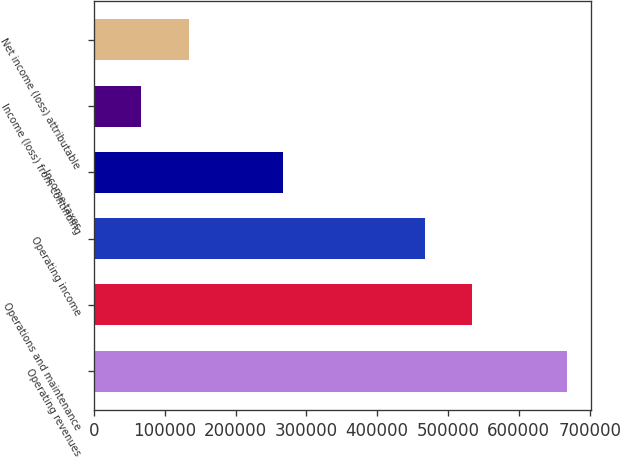Convert chart. <chart><loc_0><loc_0><loc_500><loc_500><bar_chart><fcel>Operating revenues<fcel>Operations and maintenance<fcel>Operating income<fcel>Income taxes<fcel>Income (loss) from continuing<fcel>Net income (loss) attributable<nl><fcel>667892<fcel>534314<fcel>467524<fcel>267157<fcel>66789.3<fcel>133578<nl></chart> 